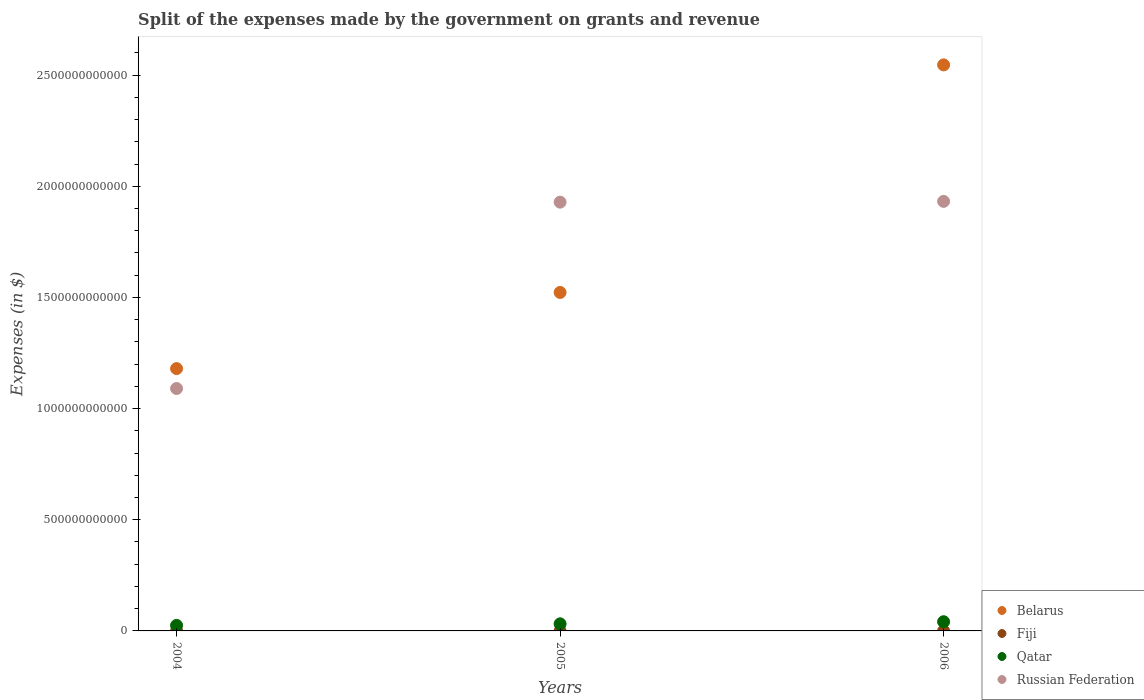How many different coloured dotlines are there?
Offer a very short reply. 4. Is the number of dotlines equal to the number of legend labels?
Offer a very short reply. Yes. What is the expenses made by the government on grants and revenue in Russian Federation in 2005?
Offer a terse response. 1.93e+12. Across all years, what is the maximum expenses made by the government on grants and revenue in Belarus?
Offer a terse response. 2.55e+12. Across all years, what is the minimum expenses made by the government on grants and revenue in Fiji?
Keep it short and to the point. 1.27e+08. In which year was the expenses made by the government on grants and revenue in Belarus maximum?
Provide a succinct answer. 2006. What is the total expenses made by the government on grants and revenue in Belarus in the graph?
Keep it short and to the point. 5.25e+12. What is the difference between the expenses made by the government on grants and revenue in Qatar in 2004 and that in 2005?
Your answer should be compact. -7.05e+09. What is the difference between the expenses made by the government on grants and revenue in Fiji in 2006 and the expenses made by the government on grants and revenue in Russian Federation in 2004?
Offer a very short reply. -1.09e+12. What is the average expenses made by the government on grants and revenue in Russian Federation per year?
Provide a succinct answer. 1.65e+12. In the year 2005, what is the difference between the expenses made by the government on grants and revenue in Russian Federation and expenses made by the government on grants and revenue in Qatar?
Provide a short and direct response. 1.90e+12. In how many years, is the expenses made by the government on grants and revenue in Qatar greater than 2000000000000 $?
Provide a short and direct response. 0. What is the ratio of the expenses made by the government on grants and revenue in Belarus in 2005 to that in 2006?
Provide a short and direct response. 0.6. Is the expenses made by the government on grants and revenue in Belarus in 2004 less than that in 2005?
Your answer should be very brief. Yes. What is the difference between the highest and the second highest expenses made by the government on grants and revenue in Fiji?
Provide a short and direct response. 1.02e+07. What is the difference between the highest and the lowest expenses made by the government on grants and revenue in Qatar?
Your answer should be compact. 1.65e+1. Is the sum of the expenses made by the government on grants and revenue in Russian Federation in 2004 and 2005 greater than the maximum expenses made by the government on grants and revenue in Qatar across all years?
Offer a terse response. Yes. Is it the case that in every year, the sum of the expenses made by the government on grants and revenue in Belarus and expenses made by the government on grants and revenue in Fiji  is greater than the expenses made by the government on grants and revenue in Russian Federation?
Give a very brief answer. No. Does the expenses made by the government on grants and revenue in Belarus monotonically increase over the years?
Provide a short and direct response. Yes. Is the expenses made by the government on grants and revenue in Belarus strictly greater than the expenses made by the government on grants and revenue in Qatar over the years?
Offer a very short reply. Yes. How many dotlines are there?
Keep it short and to the point. 4. What is the difference between two consecutive major ticks on the Y-axis?
Make the answer very short. 5.00e+11. Are the values on the major ticks of Y-axis written in scientific E-notation?
Provide a succinct answer. No. Where does the legend appear in the graph?
Your answer should be very brief. Bottom right. How many legend labels are there?
Your response must be concise. 4. What is the title of the graph?
Your response must be concise. Split of the expenses made by the government on grants and revenue. What is the label or title of the X-axis?
Keep it short and to the point. Years. What is the label or title of the Y-axis?
Ensure brevity in your answer.  Expenses (in $). What is the Expenses (in $) of Belarus in 2004?
Offer a very short reply. 1.18e+12. What is the Expenses (in $) of Fiji in 2004?
Ensure brevity in your answer.  1.27e+08. What is the Expenses (in $) of Qatar in 2004?
Make the answer very short. 2.49e+1. What is the Expenses (in $) in Russian Federation in 2004?
Offer a terse response. 1.09e+12. What is the Expenses (in $) of Belarus in 2005?
Offer a terse response. 1.52e+12. What is the Expenses (in $) of Fiji in 2005?
Ensure brevity in your answer.  1.38e+08. What is the Expenses (in $) of Qatar in 2005?
Your answer should be very brief. 3.19e+1. What is the Expenses (in $) in Russian Federation in 2005?
Provide a short and direct response. 1.93e+12. What is the Expenses (in $) of Belarus in 2006?
Ensure brevity in your answer.  2.55e+12. What is the Expenses (in $) in Fiji in 2006?
Provide a short and direct response. 1.28e+08. What is the Expenses (in $) in Qatar in 2006?
Provide a short and direct response. 4.14e+1. What is the Expenses (in $) of Russian Federation in 2006?
Ensure brevity in your answer.  1.93e+12. Across all years, what is the maximum Expenses (in $) in Belarus?
Offer a terse response. 2.55e+12. Across all years, what is the maximum Expenses (in $) of Fiji?
Ensure brevity in your answer.  1.38e+08. Across all years, what is the maximum Expenses (in $) of Qatar?
Ensure brevity in your answer.  4.14e+1. Across all years, what is the maximum Expenses (in $) in Russian Federation?
Provide a short and direct response. 1.93e+12. Across all years, what is the minimum Expenses (in $) in Belarus?
Your answer should be compact. 1.18e+12. Across all years, what is the minimum Expenses (in $) of Fiji?
Offer a terse response. 1.27e+08. Across all years, what is the minimum Expenses (in $) of Qatar?
Give a very brief answer. 2.49e+1. Across all years, what is the minimum Expenses (in $) of Russian Federation?
Keep it short and to the point. 1.09e+12. What is the total Expenses (in $) of Belarus in the graph?
Your answer should be very brief. 5.25e+12. What is the total Expenses (in $) of Fiji in the graph?
Keep it short and to the point. 3.93e+08. What is the total Expenses (in $) in Qatar in the graph?
Provide a succinct answer. 9.82e+1. What is the total Expenses (in $) in Russian Federation in the graph?
Provide a short and direct response. 4.95e+12. What is the difference between the Expenses (in $) in Belarus in 2004 and that in 2005?
Offer a very short reply. -3.43e+11. What is the difference between the Expenses (in $) of Fiji in 2004 and that in 2005?
Offer a terse response. -1.07e+07. What is the difference between the Expenses (in $) of Qatar in 2004 and that in 2005?
Keep it short and to the point. -7.05e+09. What is the difference between the Expenses (in $) in Russian Federation in 2004 and that in 2005?
Provide a short and direct response. -8.38e+11. What is the difference between the Expenses (in $) of Belarus in 2004 and that in 2006?
Your answer should be compact. -1.37e+12. What is the difference between the Expenses (in $) in Fiji in 2004 and that in 2006?
Your answer should be compact. -4.86e+05. What is the difference between the Expenses (in $) in Qatar in 2004 and that in 2006?
Make the answer very short. -1.65e+1. What is the difference between the Expenses (in $) in Russian Federation in 2004 and that in 2006?
Your answer should be very brief. -8.42e+11. What is the difference between the Expenses (in $) of Belarus in 2005 and that in 2006?
Offer a very short reply. -1.02e+12. What is the difference between the Expenses (in $) of Fiji in 2005 and that in 2006?
Provide a succinct answer. 1.02e+07. What is the difference between the Expenses (in $) of Qatar in 2005 and that in 2006?
Ensure brevity in your answer.  -9.42e+09. What is the difference between the Expenses (in $) of Russian Federation in 2005 and that in 2006?
Ensure brevity in your answer.  -3.47e+09. What is the difference between the Expenses (in $) of Belarus in 2004 and the Expenses (in $) of Fiji in 2005?
Keep it short and to the point. 1.18e+12. What is the difference between the Expenses (in $) of Belarus in 2004 and the Expenses (in $) of Qatar in 2005?
Provide a short and direct response. 1.15e+12. What is the difference between the Expenses (in $) of Belarus in 2004 and the Expenses (in $) of Russian Federation in 2005?
Keep it short and to the point. -7.49e+11. What is the difference between the Expenses (in $) of Fiji in 2004 and the Expenses (in $) of Qatar in 2005?
Offer a terse response. -3.18e+1. What is the difference between the Expenses (in $) in Fiji in 2004 and the Expenses (in $) in Russian Federation in 2005?
Offer a terse response. -1.93e+12. What is the difference between the Expenses (in $) of Qatar in 2004 and the Expenses (in $) of Russian Federation in 2005?
Ensure brevity in your answer.  -1.90e+12. What is the difference between the Expenses (in $) of Belarus in 2004 and the Expenses (in $) of Fiji in 2006?
Give a very brief answer. 1.18e+12. What is the difference between the Expenses (in $) of Belarus in 2004 and the Expenses (in $) of Qatar in 2006?
Offer a very short reply. 1.14e+12. What is the difference between the Expenses (in $) in Belarus in 2004 and the Expenses (in $) in Russian Federation in 2006?
Offer a terse response. -7.52e+11. What is the difference between the Expenses (in $) of Fiji in 2004 and the Expenses (in $) of Qatar in 2006?
Make the answer very short. -4.12e+1. What is the difference between the Expenses (in $) in Fiji in 2004 and the Expenses (in $) in Russian Federation in 2006?
Your answer should be compact. -1.93e+12. What is the difference between the Expenses (in $) in Qatar in 2004 and the Expenses (in $) in Russian Federation in 2006?
Make the answer very short. -1.91e+12. What is the difference between the Expenses (in $) in Belarus in 2005 and the Expenses (in $) in Fiji in 2006?
Your answer should be very brief. 1.52e+12. What is the difference between the Expenses (in $) of Belarus in 2005 and the Expenses (in $) of Qatar in 2006?
Your answer should be compact. 1.48e+12. What is the difference between the Expenses (in $) of Belarus in 2005 and the Expenses (in $) of Russian Federation in 2006?
Your answer should be compact. -4.10e+11. What is the difference between the Expenses (in $) of Fiji in 2005 and the Expenses (in $) of Qatar in 2006?
Keep it short and to the point. -4.12e+1. What is the difference between the Expenses (in $) in Fiji in 2005 and the Expenses (in $) in Russian Federation in 2006?
Keep it short and to the point. -1.93e+12. What is the difference between the Expenses (in $) in Qatar in 2005 and the Expenses (in $) in Russian Federation in 2006?
Give a very brief answer. -1.90e+12. What is the average Expenses (in $) in Belarus per year?
Provide a short and direct response. 1.75e+12. What is the average Expenses (in $) of Fiji per year?
Offer a terse response. 1.31e+08. What is the average Expenses (in $) in Qatar per year?
Your answer should be compact. 3.27e+1. What is the average Expenses (in $) of Russian Federation per year?
Make the answer very short. 1.65e+12. In the year 2004, what is the difference between the Expenses (in $) of Belarus and Expenses (in $) of Fiji?
Offer a terse response. 1.18e+12. In the year 2004, what is the difference between the Expenses (in $) in Belarus and Expenses (in $) in Qatar?
Your response must be concise. 1.16e+12. In the year 2004, what is the difference between the Expenses (in $) in Belarus and Expenses (in $) in Russian Federation?
Your answer should be very brief. 8.95e+1. In the year 2004, what is the difference between the Expenses (in $) of Fiji and Expenses (in $) of Qatar?
Your answer should be compact. -2.48e+1. In the year 2004, what is the difference between the Expenses (in $) of Fiji and Expenses (in $) of Russian Federation?
Offer a very short reply. -1.09e+12. In the year 2004, what is the difference between the Expenses (in $) in Qatar and Expenses (in $) in Russian Federation?
Your response must be concise. -1.07e+12. In the year 2005, what is the difference between the Expenses (in $) of Belarus and Expenses (in $) of Fiji?
Offer a very short reply. 1.52e+12. In the year 2005, what is the difference between the Expenses (in $) of Belarus and Expenses (in $) of Qatar?
Keep it short and to the point. 1.49e+12. In the year 2005, what is the difference between the Expenses (in $) of Belarus and Expenses (in $) of Russian Federation?
Ensure brevity in your answer.  -4.06e+11. In the year 2005, what is the difference between the Expenses (in $) in Fiji and Expenses (in $) in Qatar?
Your response must be concise. -3.18e+1. In the year 2005, what is the difference between the Expenses (in $) of Fiji and Expenses (in $) of Russian Federation?
Keep it short and to the point. -1.93e+12. In the year 2005, what is the difference between the Expenses (in $) of Qatar and Expenses (in $) of Russian Federation?
Keep it short and to the point. -1.90e+12. In the year 2006, what is the difference between the Expenses (in $) of Belarus and Expenses (in $) of Fiji?
Keep it short and to the point. 2.55e+12. In the year 2006, what is the difference between the Expenses (in $) of Belarus and Expenses (in $) of Qatar?
Keep it short and to the point. 2.50e+12. In the year 2006, what is the difference between the Expenses (in $) of Belarus and Expenses (in $) of Russian Federation?
Keep it short and to the point. 6.14e+11. In the year 2006, what is the difference between the Expenses (in $) of Fiji and Expenses (in $) of Qatar?
Make the answer very short. -4.12e+1. In the year 2006, what is the difference between the Expenses (in $) in Fiji and Expenses (in $) in Russian Federation?
Offer a terse response. -1.93e+12. In the year 2006, what is the difference between the Expenses (in $) in Qatar and Expenses (in $) in Russian Federation?
Provide a short and direct response. -1.89e+12. What is the ratio of the Expenses (in $) of Belarus in 2004 to that in 2005?
Provide a succinct answer. 0.78. What is the ratio of the Expenses (in $) in Fiji in 2004 to that in 2005?
Provide a short and direct response. 0.92. What is the ratio of the Expenses (in $) of Qatar in 2004 to that in 2005?
Give a very brief answer. 0.78. What is the ratio of the Expenses (in $) of Russian Federation in 2004 to that in 2005?
Offer a very short reply. 0.57. What is the ratio of the Expenses (in $) in Belarus in 2004 to that in 2006?
Make the answer very short. 0.46. What is the ratio of the Expenses (in $) of Fiji in 2004 to that in 2006?
Ensure brevity in your answer.  1. What is the ratio of the Expenses (in $) of Qatar in 2004 to that in 2006?
Give a very brief answer. 0.6. What is the ratio of the Expenses (in $) in Russian Federation in 2004 to that in 2006?
Ensure brevity in your answer.  0.56. What is the ratio of the Expenses (in $) in Belarus in 2005 to that in 2006?
Your answer should be compact. 0.6. What is the ratio of the Expenses (in $) in Fiji in 2005 to that in 2006?
Provide a short and direct response. 1.08. What is the ratio of the Expenses (in $) of Qatar in 2005 to that in 2006?
Provide a succinct answer. 0.77. What is the ratio of the Expenses (in $) of Russian Federation in 2005 to that in 2006?
Your answer should be very brief. 1. What is the difference between the highest and the second highest Expenses (in $) of Belarus?
Your answer should be very brief. 1.02e+12. What is the difference between the highest and the second highest Expenses (in $) of Fiji?
Give a very brief answer. 1.02e+07. What is the difference between the highest and the second highest Expenses (in $) in Qatar?
Provide a succinct answer. 9.42e+09. What is the difference between the highest and the second highest Expenses (in $) of Russian Federation?
Your answer should be compact. 3.47e+09. What is the difference between the highest and the lowest Expenses (in $) in Belarus?
Provide a succinct answer. 1.37e+12. What is the difference between the highest and the lowest Expenses (in $) in Fiji?
Offer a terse response. 1.07e+07. What is the difference between the highest and the lowest Expenses (in $) of Qatar?
Ensure brevity in your answer.  1.65e+1. What is the difference between the highest and the lowest Expenses (in $) of Russian Federation?
Make the answer very short. 8.42e+11. 